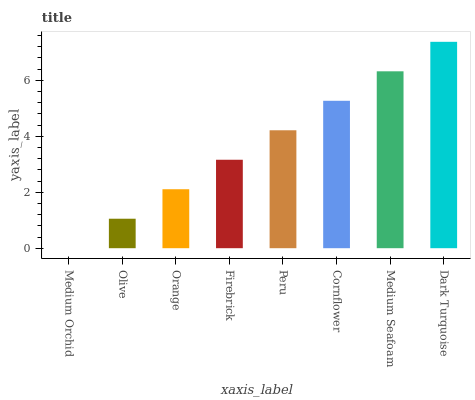Is Olive the minimum?
Answer yes or no. No. Is Olive the maximum?
Answer yes or no. No. Is Olive greater than Medium Orchid?
Answer yes or no. Yes. Is Medium Orchid less than Olive?
Answer yes or no. Yes. Is Medium Orchid greater than Olive?
Answer yes or no. No. Is Olive less than Medium Orchid?
Answer yes or no. No. Is Peru the high median?
Answer yes or no. Yes. Is Firebrick the low median?
Answer yes or no. Yes. Is Orange the high median?
Answer yes or no. No. Is Orange the low median?
Answer yes or no. No. 